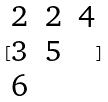Convert formula to latex. <formula><loc_0><loc_0><loc_500><loc_500>[ \begin{matrix} 2 & 2 & 4 \\ 3 & 5 \\ 6 \end{matrix} ]</formula> 